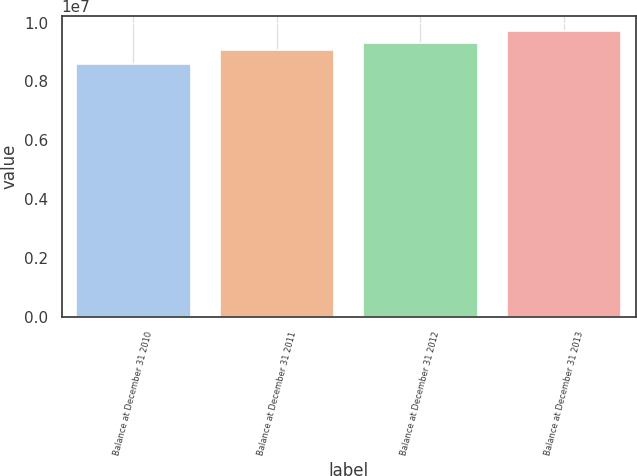Convert chart to OTSL. <chart><loc_0><loc_0><loc_500><loc_500><bar_chart><fcel>Balance at December 31 2010<fcel>Balance at December 31 2011<fcel>Balance at December 31 2012<fcel>Balance at December 31 2013<nl><fcel>8.5904e+06<fcel>9.05527e+06<fcel>9.29109e+06<fcel>9.72647e+06<nl></chart> 